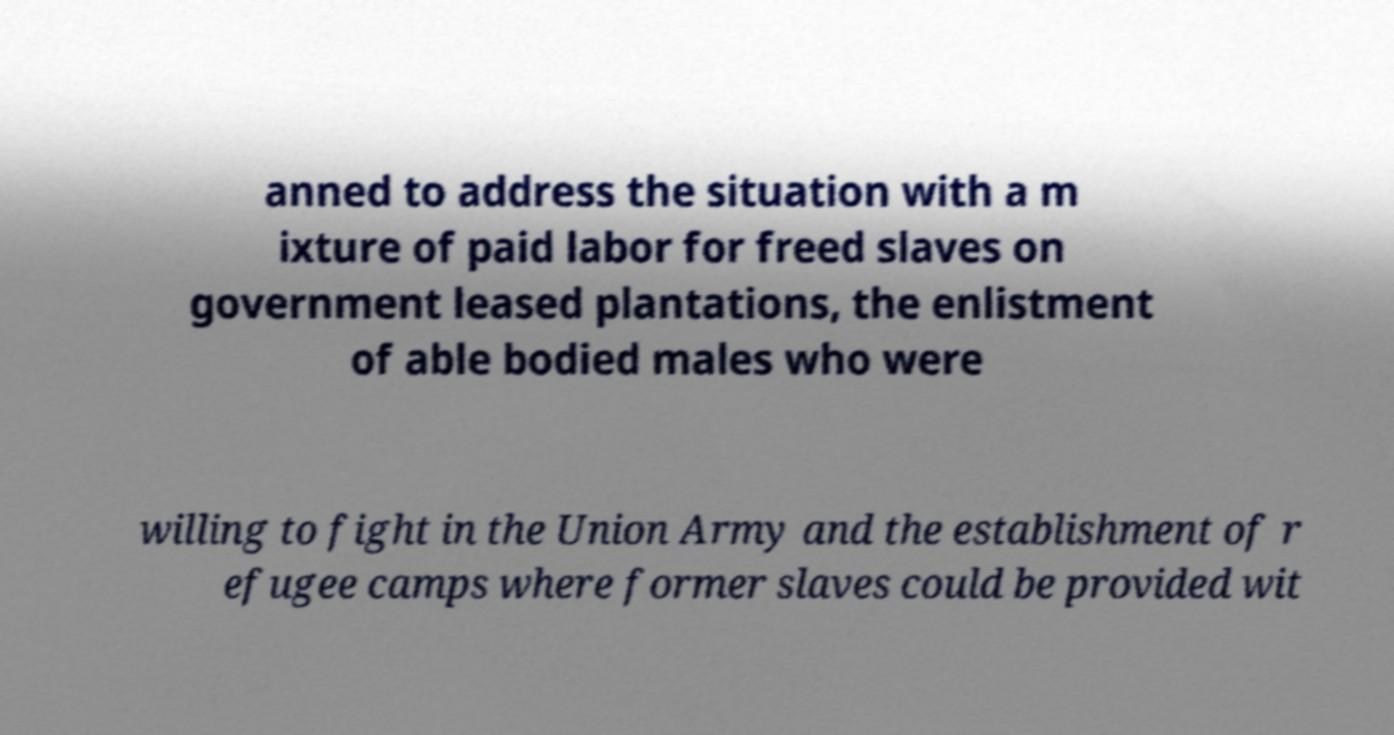What messages or text are displayed in this image? I need them in a readable, typed format. anned to address the situation with a m ixture of paid labor for freed slaves on government leased plantations, the enlistment of able bodied males who were willing to fight in the Union Army and the establishment of r efugee camps where former slaves could be provided wit 